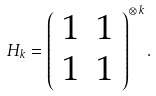Convert formula to latex. <formula><loc_0><loc_0><loc_500><loc_500>H _ { k } = \left ( \begin{array} { c c } 1 & 1 \\ 1 & 1 \end{array} \right ) ^ { \otimes \, k } .</formula> 